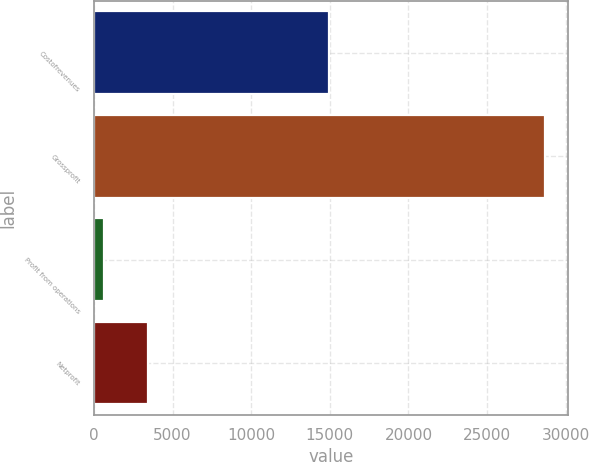Convert chart. <chart><loc_0><loc_0><loc_500><loc_500><bar_chart><fcel>Costofrevenues<fcel>Grossprofit<fcel>Profit from operations<fcel>Netprofit<nl><fcel>14961<fcel>28694<fcel>656<fcel>3459.8<nl></chart> 